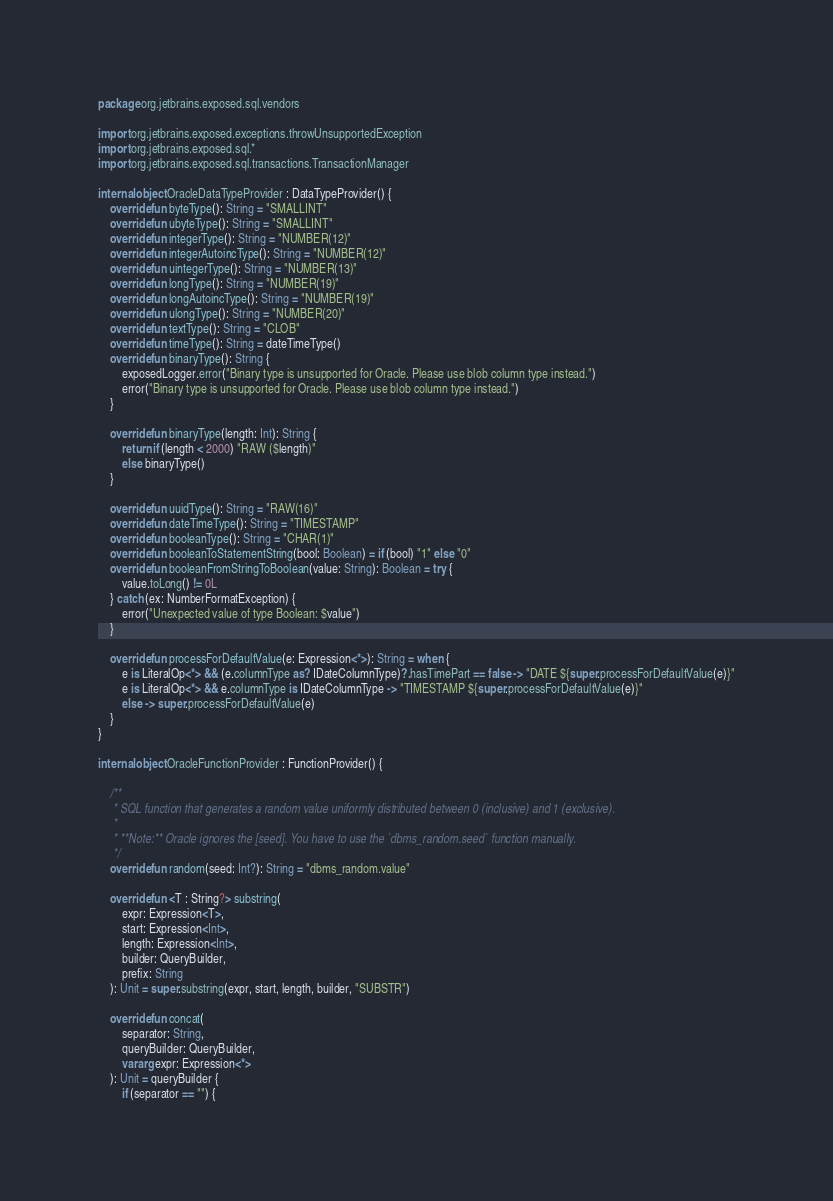Convert code to text. <code><loc_0><loc_0><loc_500><loc_500><_Kotlin_>package org.jetbrains.exposed.sql.vendors

import org.jetbrains.exposed.exceptions.throwUnsupportedException
import org.jetbrains.exposed.sql.*
import org.jetbrains.exposed.sql.transactions.TransactionManager

internal object OracleDataTypeProvider : DataTypeProvider() {
    override fun byteType(): String = "SMALLINT"
    override fun ubyteType(): String = "SMALLINT"
    override fun integerType(): String = "NUMBER(12)"
    override fun integerAutoincType(): String = "NUMBER(12)"
    override fun uintegerType(): String = "NUMBER(13)"
    override fun longType(): String = "NUMBER(19)"
    override fun longAutoincType(): String = "NUMBER(19)"
    override fun ulongType(): String = "NUMBER(20)"
    override fun textType(): String = "CLOB"
    override fun timeType(): String = dateTimeType()
    override fun binaryType(): String {
        exposedLogger.error("Binary type is unsupported for Oracle. Please use blob column type instead.")
        error("Binary type is unsupported for Oracle. Please use blob column type instead.")
    }

    override fun binaryType(length: Int): String {
        return if (length < 2000) "RAW ($length)"
        else binaryType()
    }

    override fun uuidType(): String = "RAW(16)"
    override fun dateTimeType(): String = "TIMESTAMP"
    override fun booleanType(): String = "CHAR(1)"
    override fun booleanToStatementString(bool: Boolean) = if (bool) "1" else "0"
    override fun booleanFromStringToBoolean(value: String): Boolean = try {
        value.toLong() != 0L
    } catch (ex: NumberFormatException) {
        error("Unexpected value of type Boolean: $value")
    }

    override fun processForDefaultValue(e: Expression<*>): String = when {
        e is LiteralOp<*> && (e.columnType as? IDateColumnType)?.hasTimePart == false -> "DATE ${super.processForDefaultValue(e)}"
        e is LiteralOp<*> && e.columnType is IDateColumnType -> "TIMESTAMP ${super.processForDefaultValue(e)}"
        else -> super.processForDefaultValue(e)
    }
}

internal object OracleFunctionProvider : FunctionProvider() {

    /**
     * SQL function that generates a random value uniformly distributed between 0 (inclusive) and 1 (exclusive).
     *
     * **Note:** Oracle ignores the [seed]. You have to use the `dbms_random.seed` function manually.
     */
    override fun random(seed: Int?): String = "dbms_random.value"

    override fun <T : String?> substring(
        expr: Expression<T>,
        start: Expression<Int>,
        length: Expression<Int>,
        builder: QueryBuilder,
        prefix: String
    ): Unit = super.substring(expr, start, length, builder, "SUBSTR")

    override fun concat(
        separator: String,
        queryBuilder: QueryBuilder,
        vararg expr: Expression<*>
    ): Unit = queryBuilder {
        if (separator == "") {</code> 